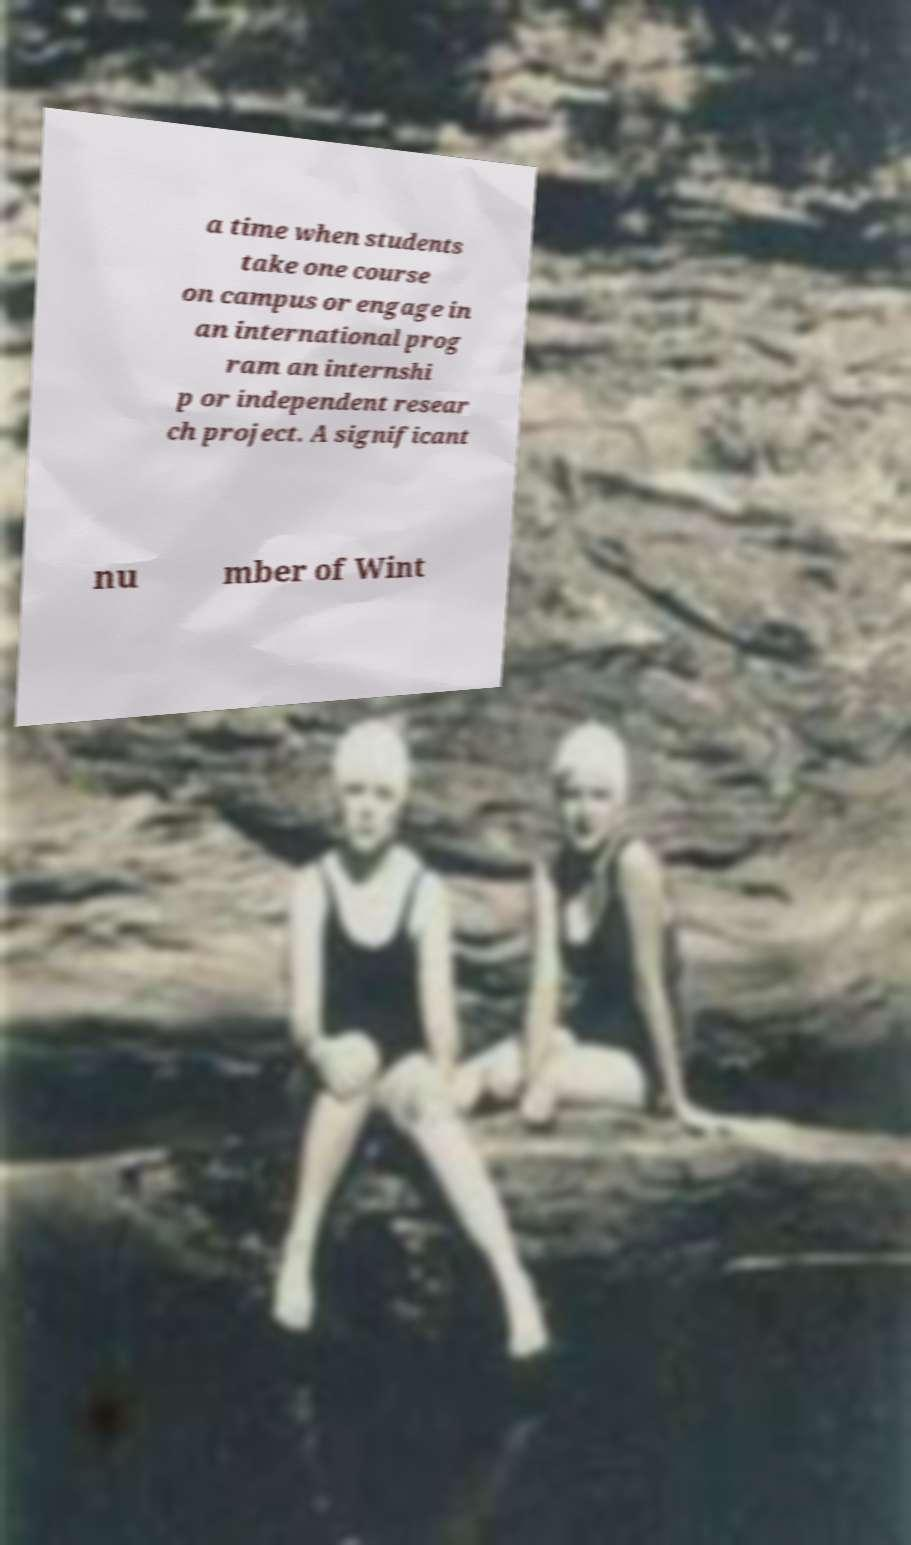Please identify and transcribe the text found in this image. a time when students take one course on campus or engage in an international prog ram an internshi p or independent resear ch project. A significant nu mber of Wint 